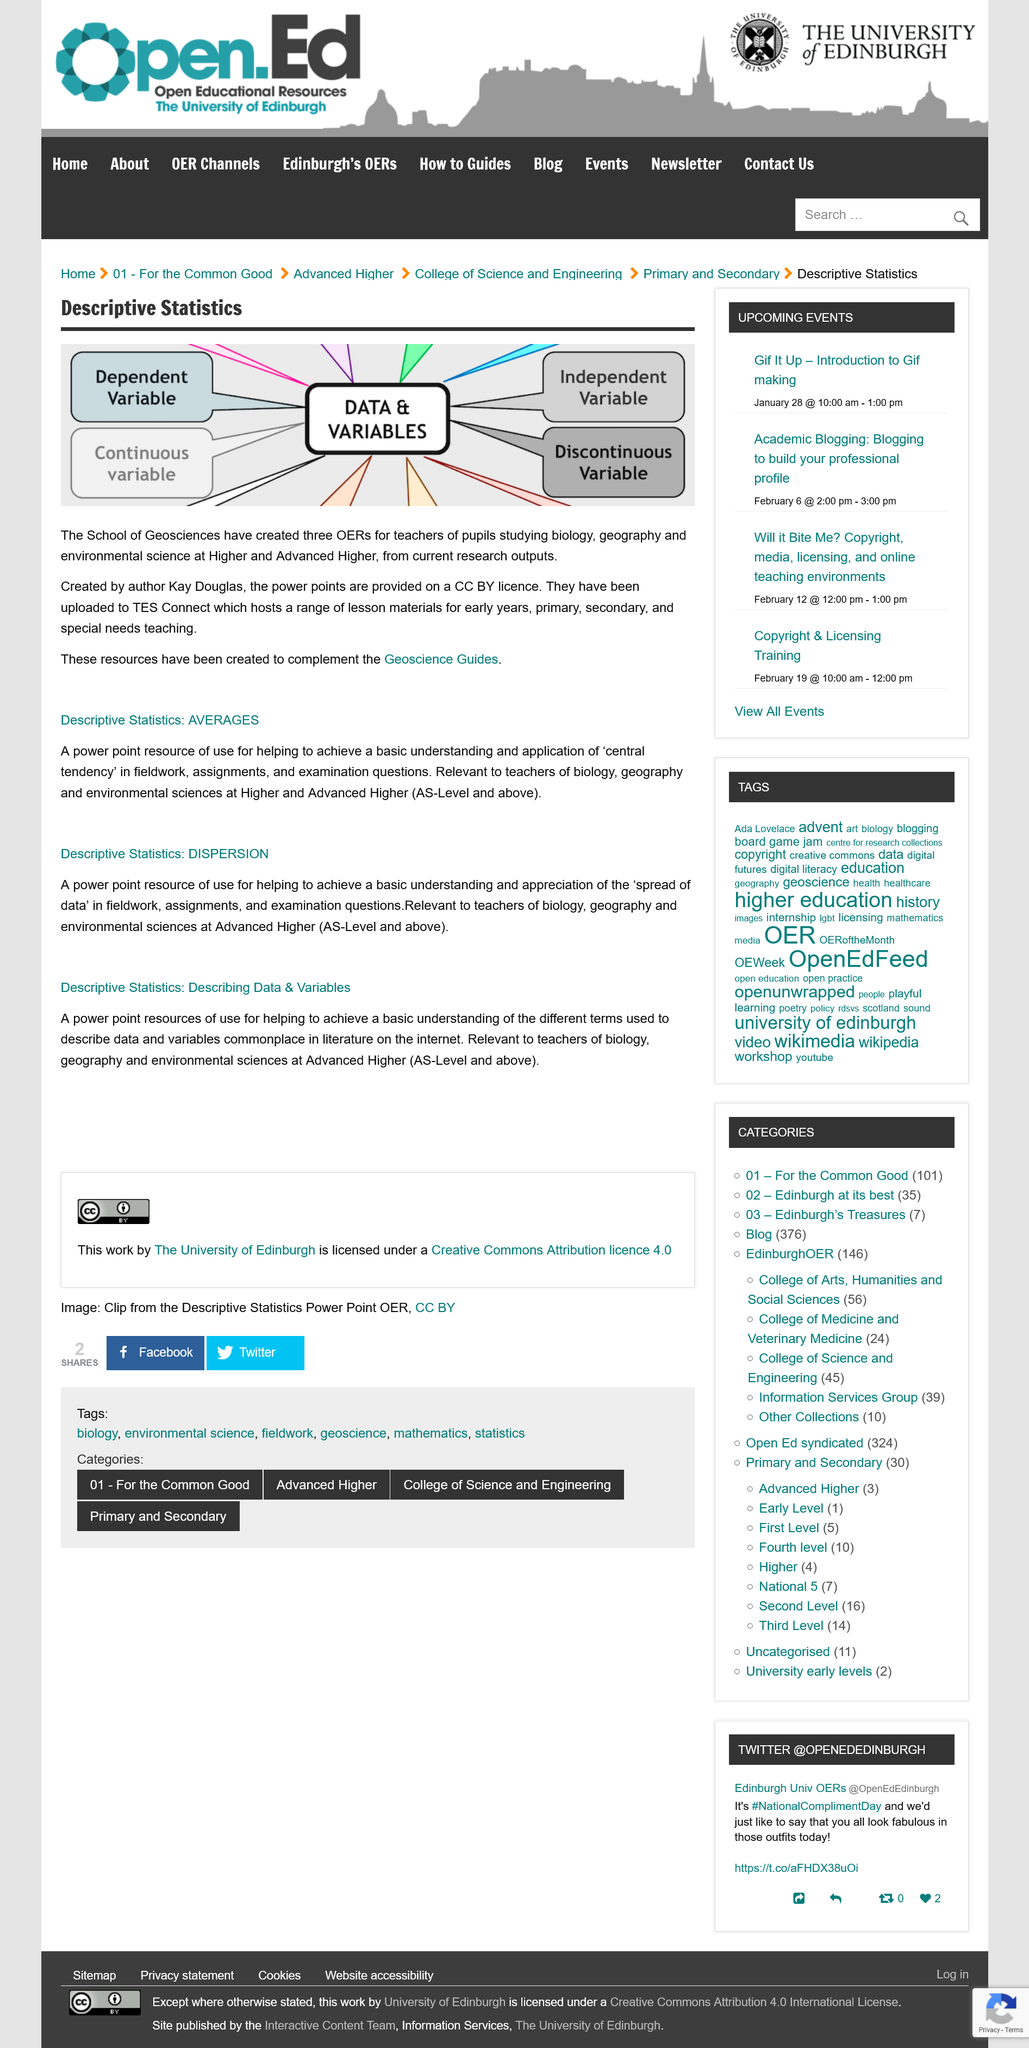Draw attention to some important aspects in this diagram. Describing data and variables helps us to achieve a basic understanding of the different terms used to describe data and variables, which is a common occurrence in our daily language. The School of Geosciences has created the three OERs. Dispersion helps us understand the spread of data, which in turn allows us to better appreciate the diversity and complexity of the world around us. The power points mentioned have been uploaded to TES Connect. Three OERs have been created for teaching and learning purposes, specifically for Biology, Geography, and Environmental Science subjects. 